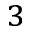<formula> <loc_0><loc_0><loc_500><loc_500>^ { 3 }</formula> 